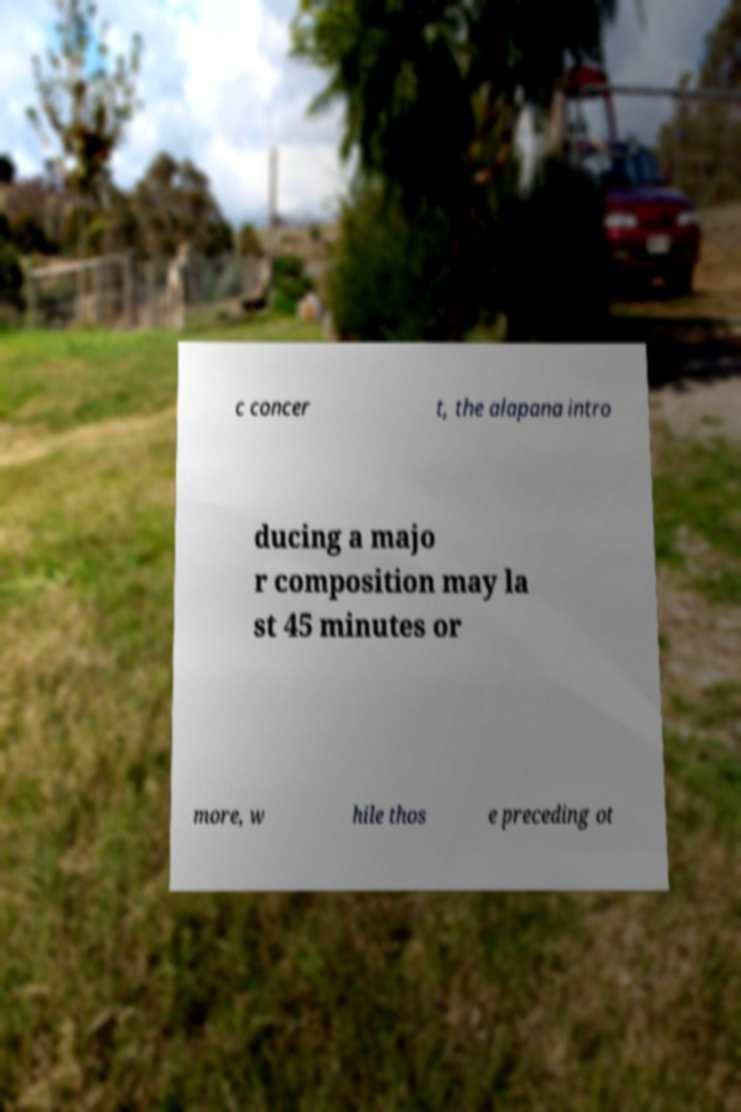Can you accurately transcribe the text from the provided image for me? c concer t, the alapana intro ducing a majo r composition may la st 45 minutes or more, w hile thos e preceding ot 